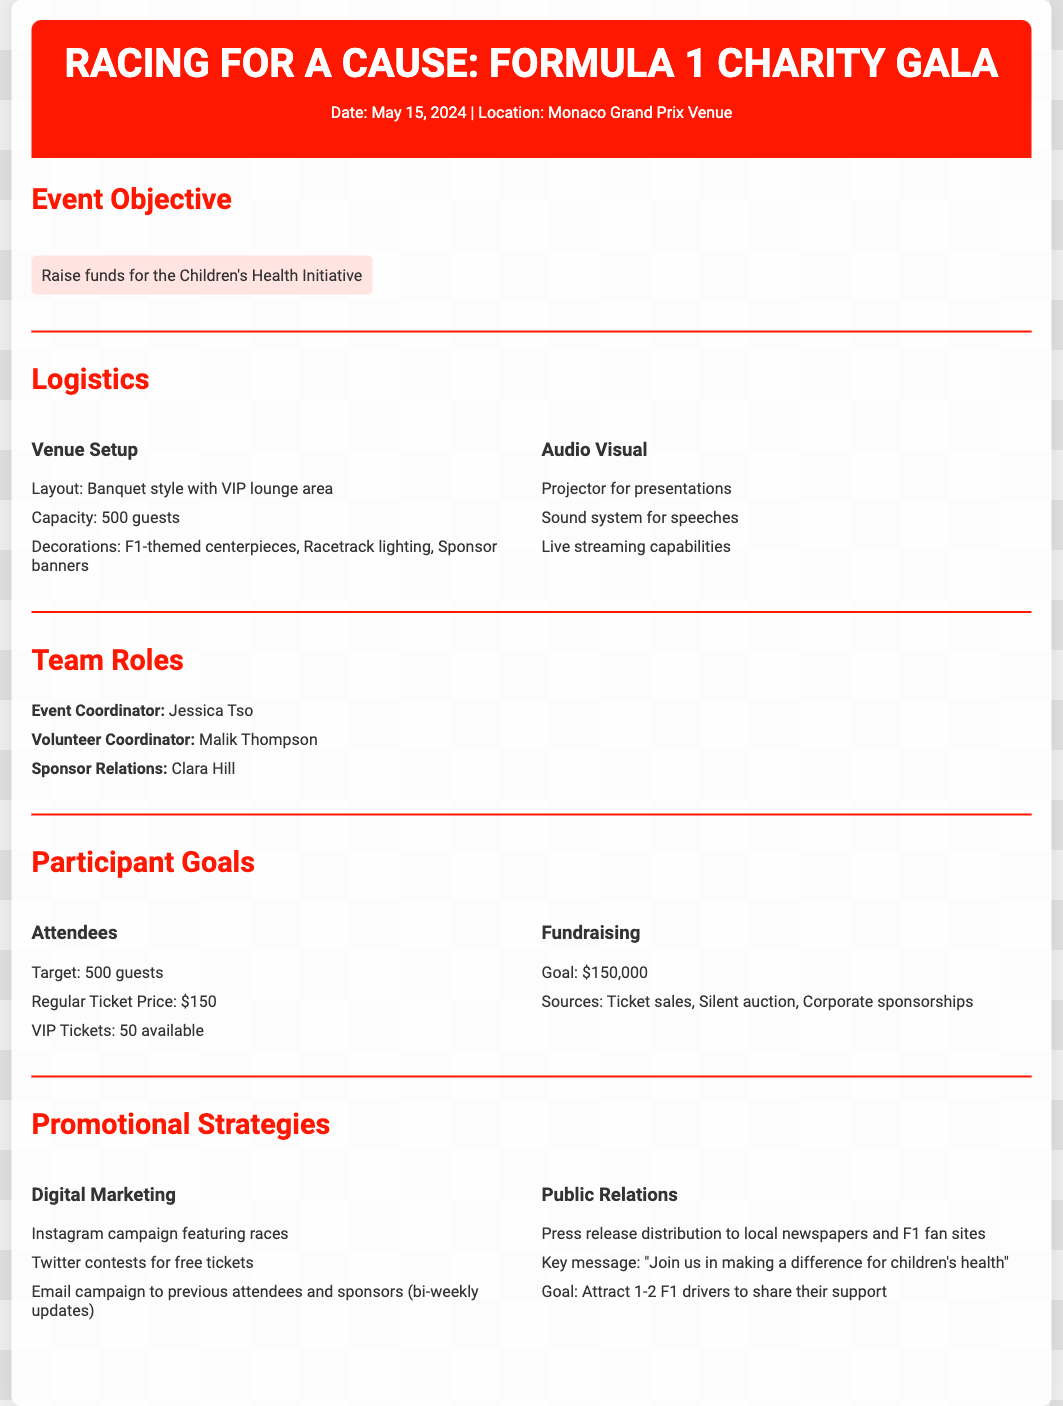What is the date of the event? The date of the event is explicitly mentioned in the header section of the document.
Answer: May 15, 2024 What is the goal of the charity event? The goal is specified under the Event Objective section of the document.
Answer: Raise funds for the Children's Health Initiative Who is the Event Coordinator? The name is listed in the Team Roles section of the document.
Answer: Jessica Tso What is the target number of attendees? The target is found in the Participant Goals section of the document.
Answer: 500 guests How much money is the fundraising goal? The goal is mentioned clearly in the Participant Goals section.
Answer: $150,000 What kind of ticket is available for VIP access? The types of tickets are listed in the Participant Goals section of the document.
Answer: VIP Tickets What are the sources of fundraising mentioned? The sources are outlined in the Fundraising subsection of the Participant Goals section.
Answer: Ticket sales, Silent auction, Corporate sponsorships What is a key message for the public relations strategy? The message is found under the Public Relations section in the document.
Answer: "Join us in making a difference for children's health" What is the name of the Volunteer Coordinator? The name is directly listed in the Team Roles section of the document.
Answer: Malik Thompson 